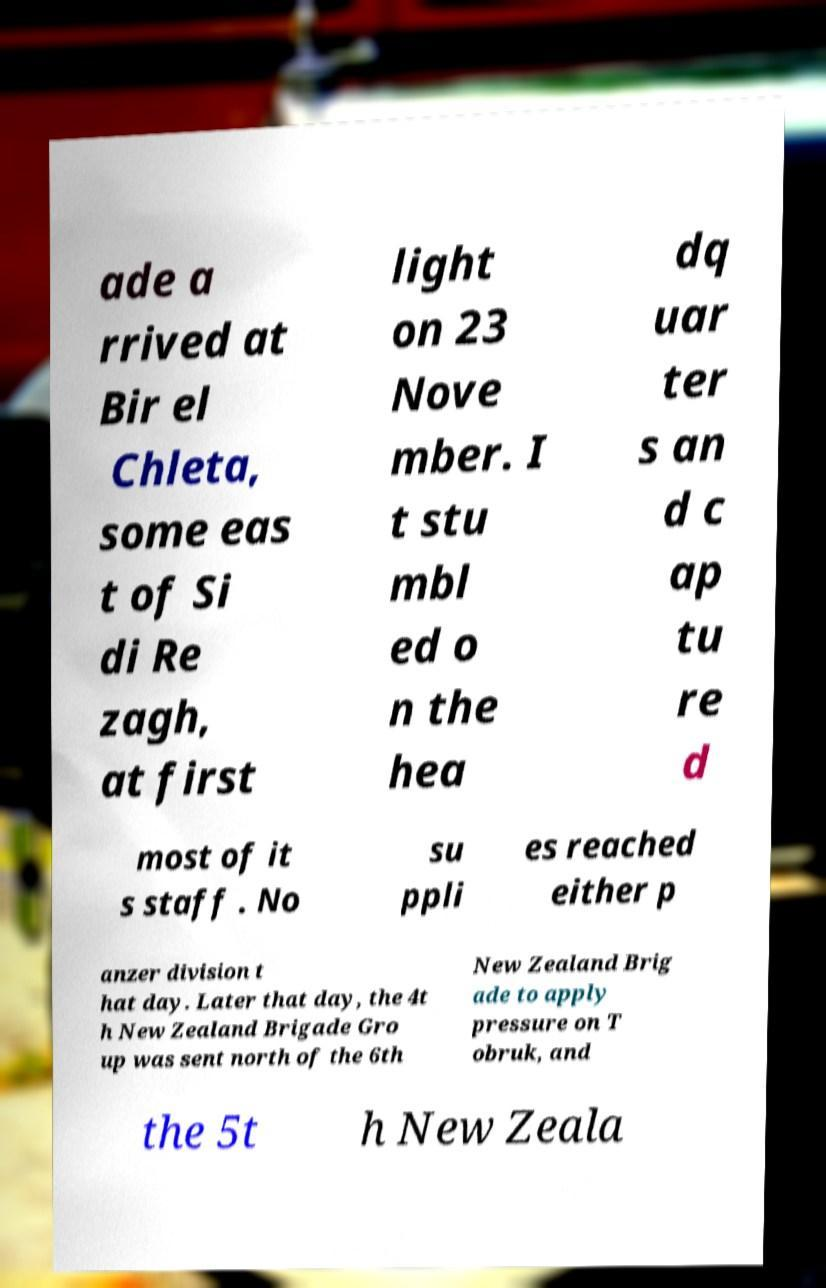Could you extract and type out the text from this image? ade a rrived at Bir el Chleta, some eas t of Si di Re zagh, at first light on 23 Nove mber. I t stu mbl ed o n the hea dq uar ter s an d c ap tu re d most of it s staff . No su ppli es reached either p anzer division t hat day. Later that day, the 4t h New Zealand Brigade Gro up was sent north of the 6th New Zealand Brig ade to apply pressure on T obruk, and the 5t h New Zeala 